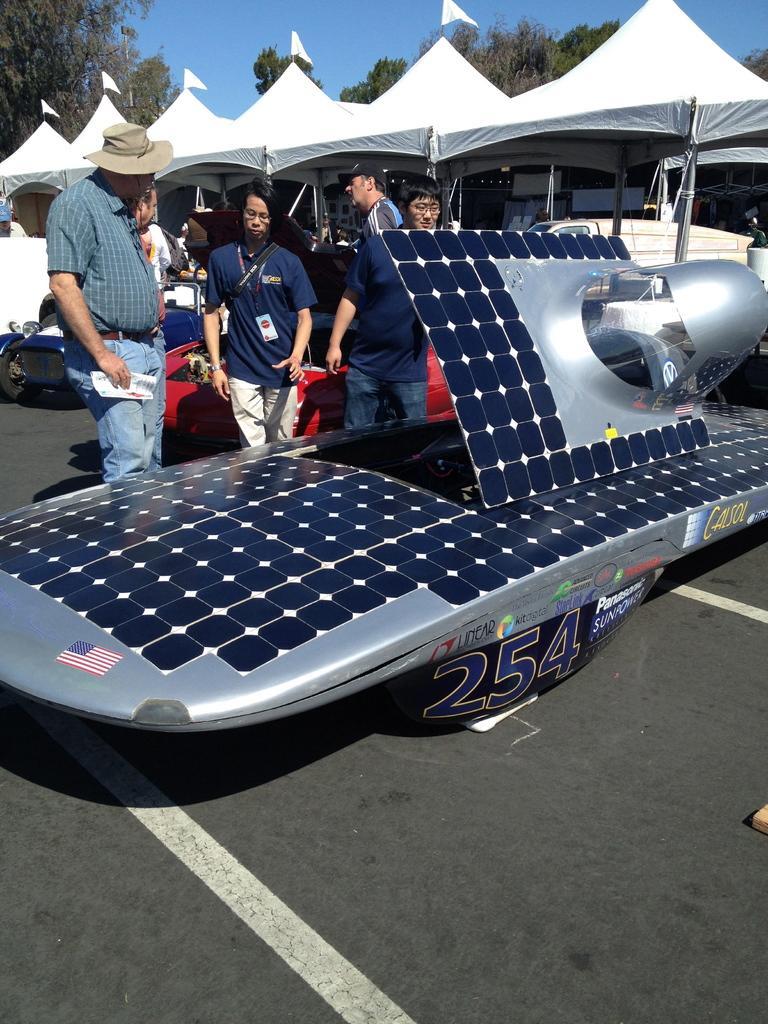Please provide a concise description of this image. In this image we can see many trees. There is a sky in the image. There are many people in the image. A person is holding an object in his hand at the left side of the image. There are many vehicles in the image. There is a some text on the car. A person is wearing objects in the image. 